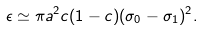Convert formula to latex. <formula><loc_0><loc_0><loc_500><loc_500>\epsilon \simeq \pi a ^ { 2 } c ( 1 - c ) ( \sigma _ { 0 } - \sigma _ { 1 } ) ^ { 2 } .</formula> 